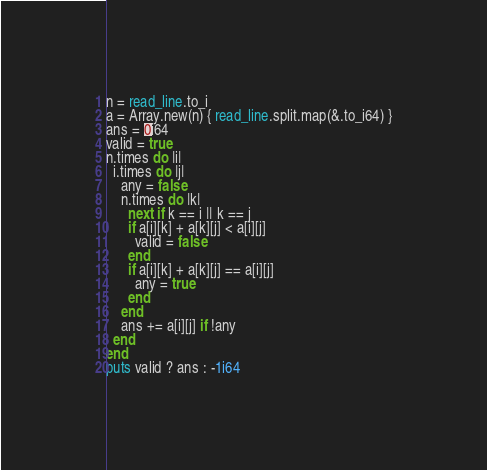Convert code to text. <code><loc_0><loc_0><loc_500><loc_500><_Crystal_>n = read_line.to_i
a = Array.new(n) { read_line.split.map(&.to_i64) }
ans = 0i64
valid = true
n.times do |i|
  i.times do |j|
    any = false
    n.times do |k|
      next if k == i || k == j
      if a[i][k] + a[k][j] < a[i][j]
        valid = false
      end
      if a[i][k] + a[k][j] == a[i][j]
        any = true
      end
    end
    ans += a[i][j] if !any
  end
end
puts valid ? ans : -1i64
</code> 